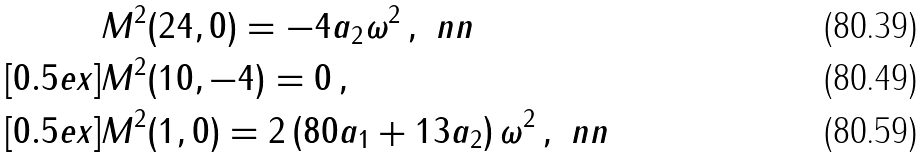<formula> <loc_0><loc_0><loc_500><loc_500>& M ^ { 2 } ( 2 4 , 0 ) = - 4 a _ { 2 } \omega ^ { 2 } \, , \ n n \\ [ 0 . 5 e x ] & M ^ { 2 } ( 1 0 , - 4 ) = 0 \, , \\ [ 0 . 5 e x ] & M ^ { 2 } ( 1 , 0 ) = 2 \left ( 8 0 a _ { 1 } + 1 3 a _ { 2 } \right ) \omega ^ { 2 } \, , \ n n</formula> 